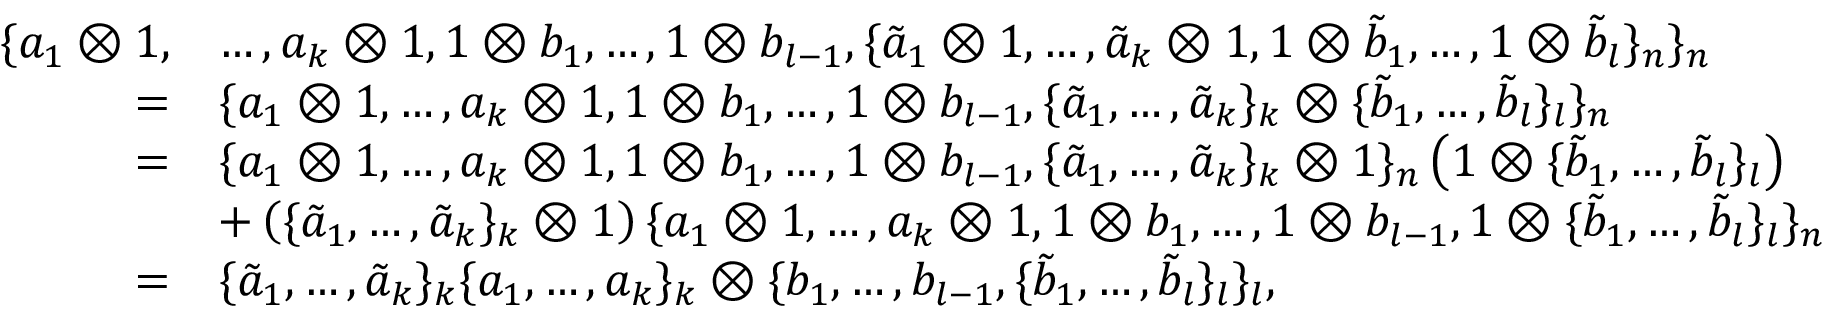Convert formula to latex. <formula><loc_0><loc_0><loc_500><loc_500>\begin{array} { r l } { \{ a _ { 1 } \otimes 1 , } & { \dots , a _ { k } \otimes 1 , 1 \otimes b _ { 1 } , \dots , 1 \otimes b _ { l - 1 } , \{ \tilde { a } _ { 1 } \otimes 1 , \dots , \tilde { a } _ { k } \otimes 1 , 1 \otimes \tilde { b } _ { 1 } , \dots , 1 \otimes \tilde { b } _ { l } \} _ { n } \} _ { n } } \\ { = } & { \{ a _ { 1 } \otimes 1 , \dots , a _ { k } \otimes 1 , 1 \otimes b _ { 1 } , \dots , 1 \otimes b _ { l - 1 } , \{ \tilde { a } _ { 1 } , \dots , \tilde { a } _ { k } \} _ { k } \otimes \{ \tilde { b } _ { 1 } , \dots , \tilde { b } _ { l } \} _ { l } \} _ { n } } \\ { = } & { \{ a _ { 1 } \otimes 1 , \dots , a _ { k } \otimes 1 , 1 \otimes b _ { 1 } , \dots , 1 \otimes b _ { l - 1 } , \{ \tilde { a } _ { 1 } , \dots , \tilde { a } _ { k } \} _ { k } \otimes { 1 } \} _ { n } \left ( 1 \otimes \{ \tilde { b } _ { 1 } , \dots , \tilde { b } _ { l } \} _ { l } \right ) } \\ & { + \left ( \{ \tilde { a } _ { 1 } , \dots , \tilde { a } _ { k } \} _ { k } \otimes 1 \right ) \{ a _ { 1 } \otimes 1 , \dots , a _ { k } \otimes 1 , 1 \otimes b _ { 1 } , \dots , 1 \otimes b _ { l - 1 } , 1 \otimes \{ \tilde { b } _ { 1 } , \dots , \tilde { b } _ { l } \} _ { l } \} _ { n } } \\ { = } & { \{ \tilde { a } _ { 1 } , \dots , \tilde { a } _ { k } \} _ { k } \{ a _ { 1 } , \dots , a _ { k } \} _ { k } \otimes \{ b _ { 1 } , \dots , b _ { l - 1 } , \{ \tilde { b } _ { 1 } , \dots , \tilde { b } _ { l } \} _ { l } \} _ { l } , } \end{array}</formula> 